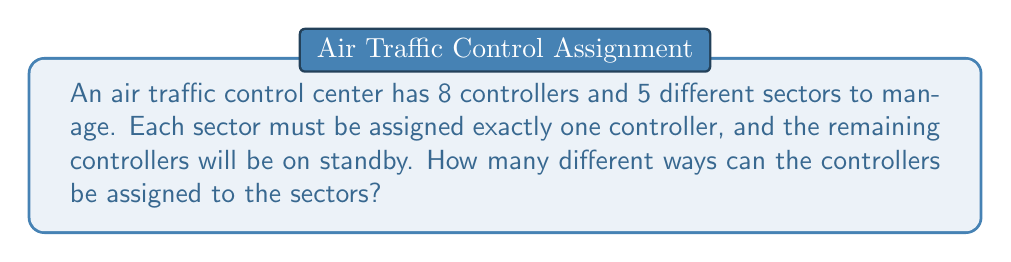Can you answer this question? Let's approach this step-by-step:

1) This is a permutation problem, as the order of assignment matters (each sector gets a specific controller).

2) We need to select 5 controllers out of 8 to assign to the 5 sectors, and then arrange these 5 in the 5 sectors.

3) The number of ways to select 5 controllers out of 8 is given by the combination formula:

   $$\binom{8}{5} = \frac{8!}{5!(8-5)!} = \frac{8!}{5!3!}$$

4) Once we have selected 5 controllers, we need to arrange them in the 5 sectors. This is a permutation of 5 elements, which is simply 5!.

5) By the multiplication principle, the total number of ways to assign the controllers is:

   $$\binom{8}{5} \times 5!$$

6) Let's calculate this:

   $$\binom{8}{5} = \frac{8!}{5!3!} = \frac{8 \times 7 \times 6}{3 \times 2 \times 1} = 56$$

   $$56 \times 5! = 56 \times 120 = 6,720$$

Therefore, there are 6,720 different ways to assign the controllers to the sectors.
Answer: 6,720 